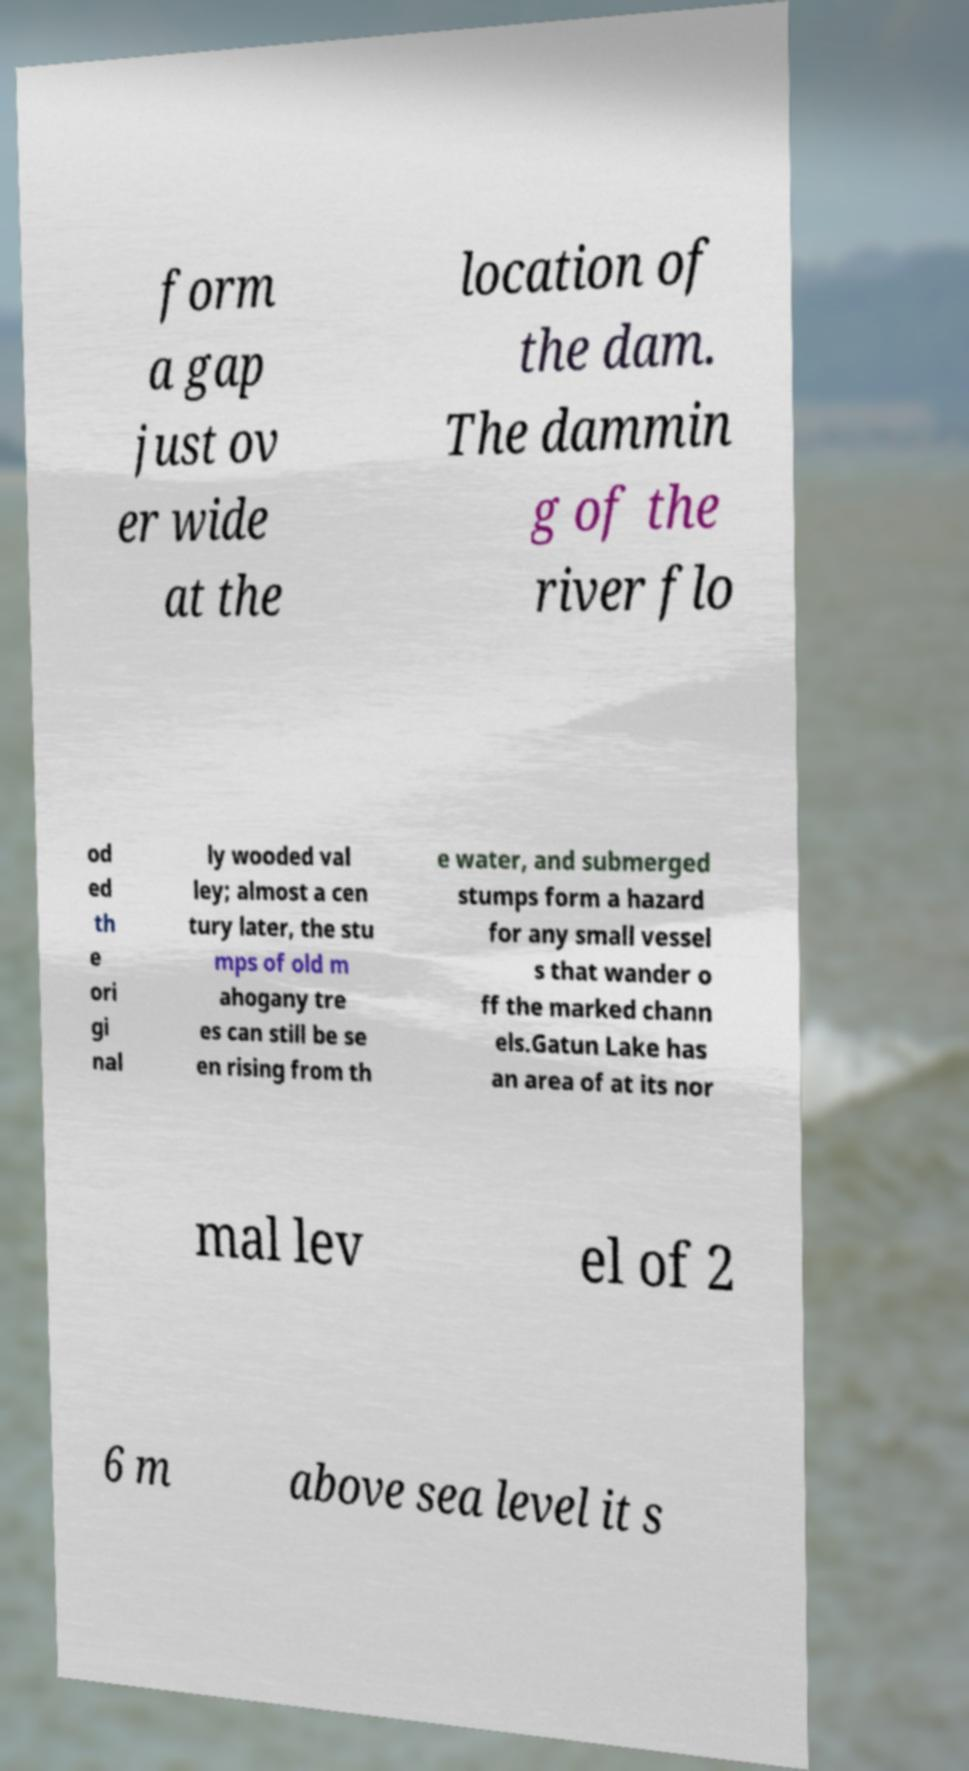Can you accurately transcribe the text from the provided image for me? form a gap just ov er wide at the location of the dam. The dammin g of the river flo od ed th e ori gi nal ly wooded val ley; almost a cen tury later, the stu mps of old m ahogany tre es can still be se en rising from th e water, and submerged stumps form a hazard for any small vessel s that wander o ff the marked chann els.Gatun Lake has an area of at its nor mal lev el of 2 6 m above sea level it s 